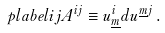Convert formula to latex. <formula><loc_0><loc_0><loc_500><loc_500>\ p l a b e l { i j } A ^ { i j } \equiv u ^ { i } _ { \underline { m } } d u ^ { \underline { m } j } \, .</formula> 